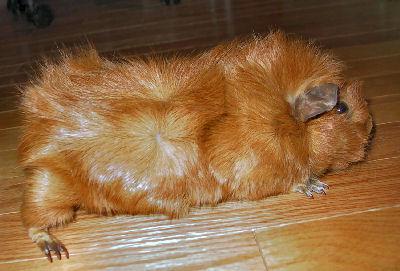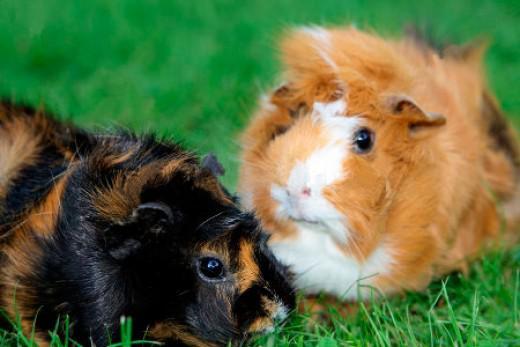The first image is the image on the left, the second image is the image on the right. For the images shown, is this caption "There are three guinea pigs." true? Answer yes or no. Yes. 